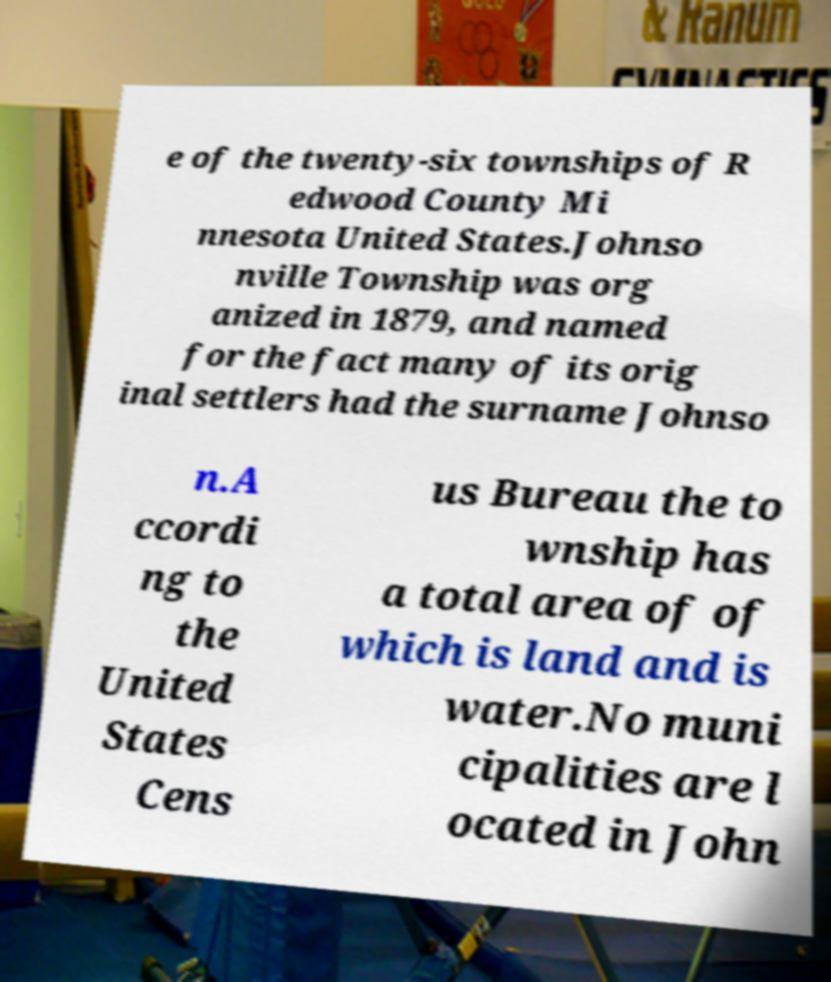Could you assist in decoding the text presented in this image and type it out clearly? e of the twenty-six townships of R edwood County Mi nnesota United States.Johnso nville Township was org anized in 1879, and named for the fact many of its orig inal settlers had the surname Johnso n.A ccordi ng to the United States Cens us Bureau the to wnship has a total area of of which is land and is water.No muni cipalities are l ocated in John 